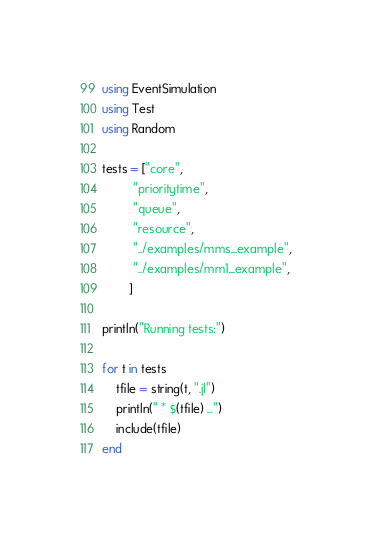<code> <loc_0><loc_0><loc_500><loc_500><_Julia_>using EventSimulation
using Test
using Random

tests = ["core",
         "prioritytime",
         "queue",
         "resource",
         "../examples/mms_example",
         "../examples/mm1_example",
        ]

println("Running tests:")

for t in tests
    tfile = string(t, ".jl")
    println(" * $(tfile) ...")
    include(tfile)
end
</code> 